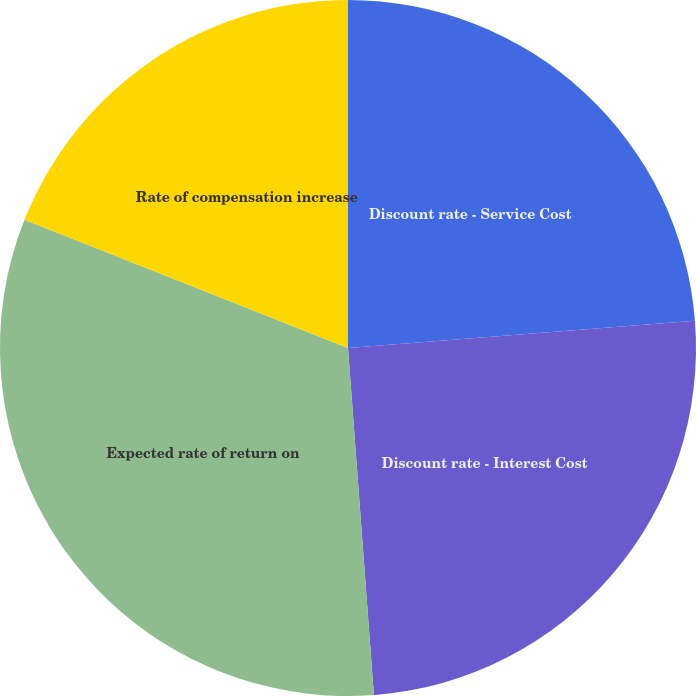Convert chart. <chart><loc_0><loc_0><loc_500><loc_500><pie_chart><fcel>Discount rate - Service Cost<fcel>Discount rate - Interest Cost<fcel>Expected rate of return on<fcel>Rate of compensation increase<nl><fcel>23.75%<fcel>25.07%<fcel>32.19%<fcel>19.0%<nl></chart> 